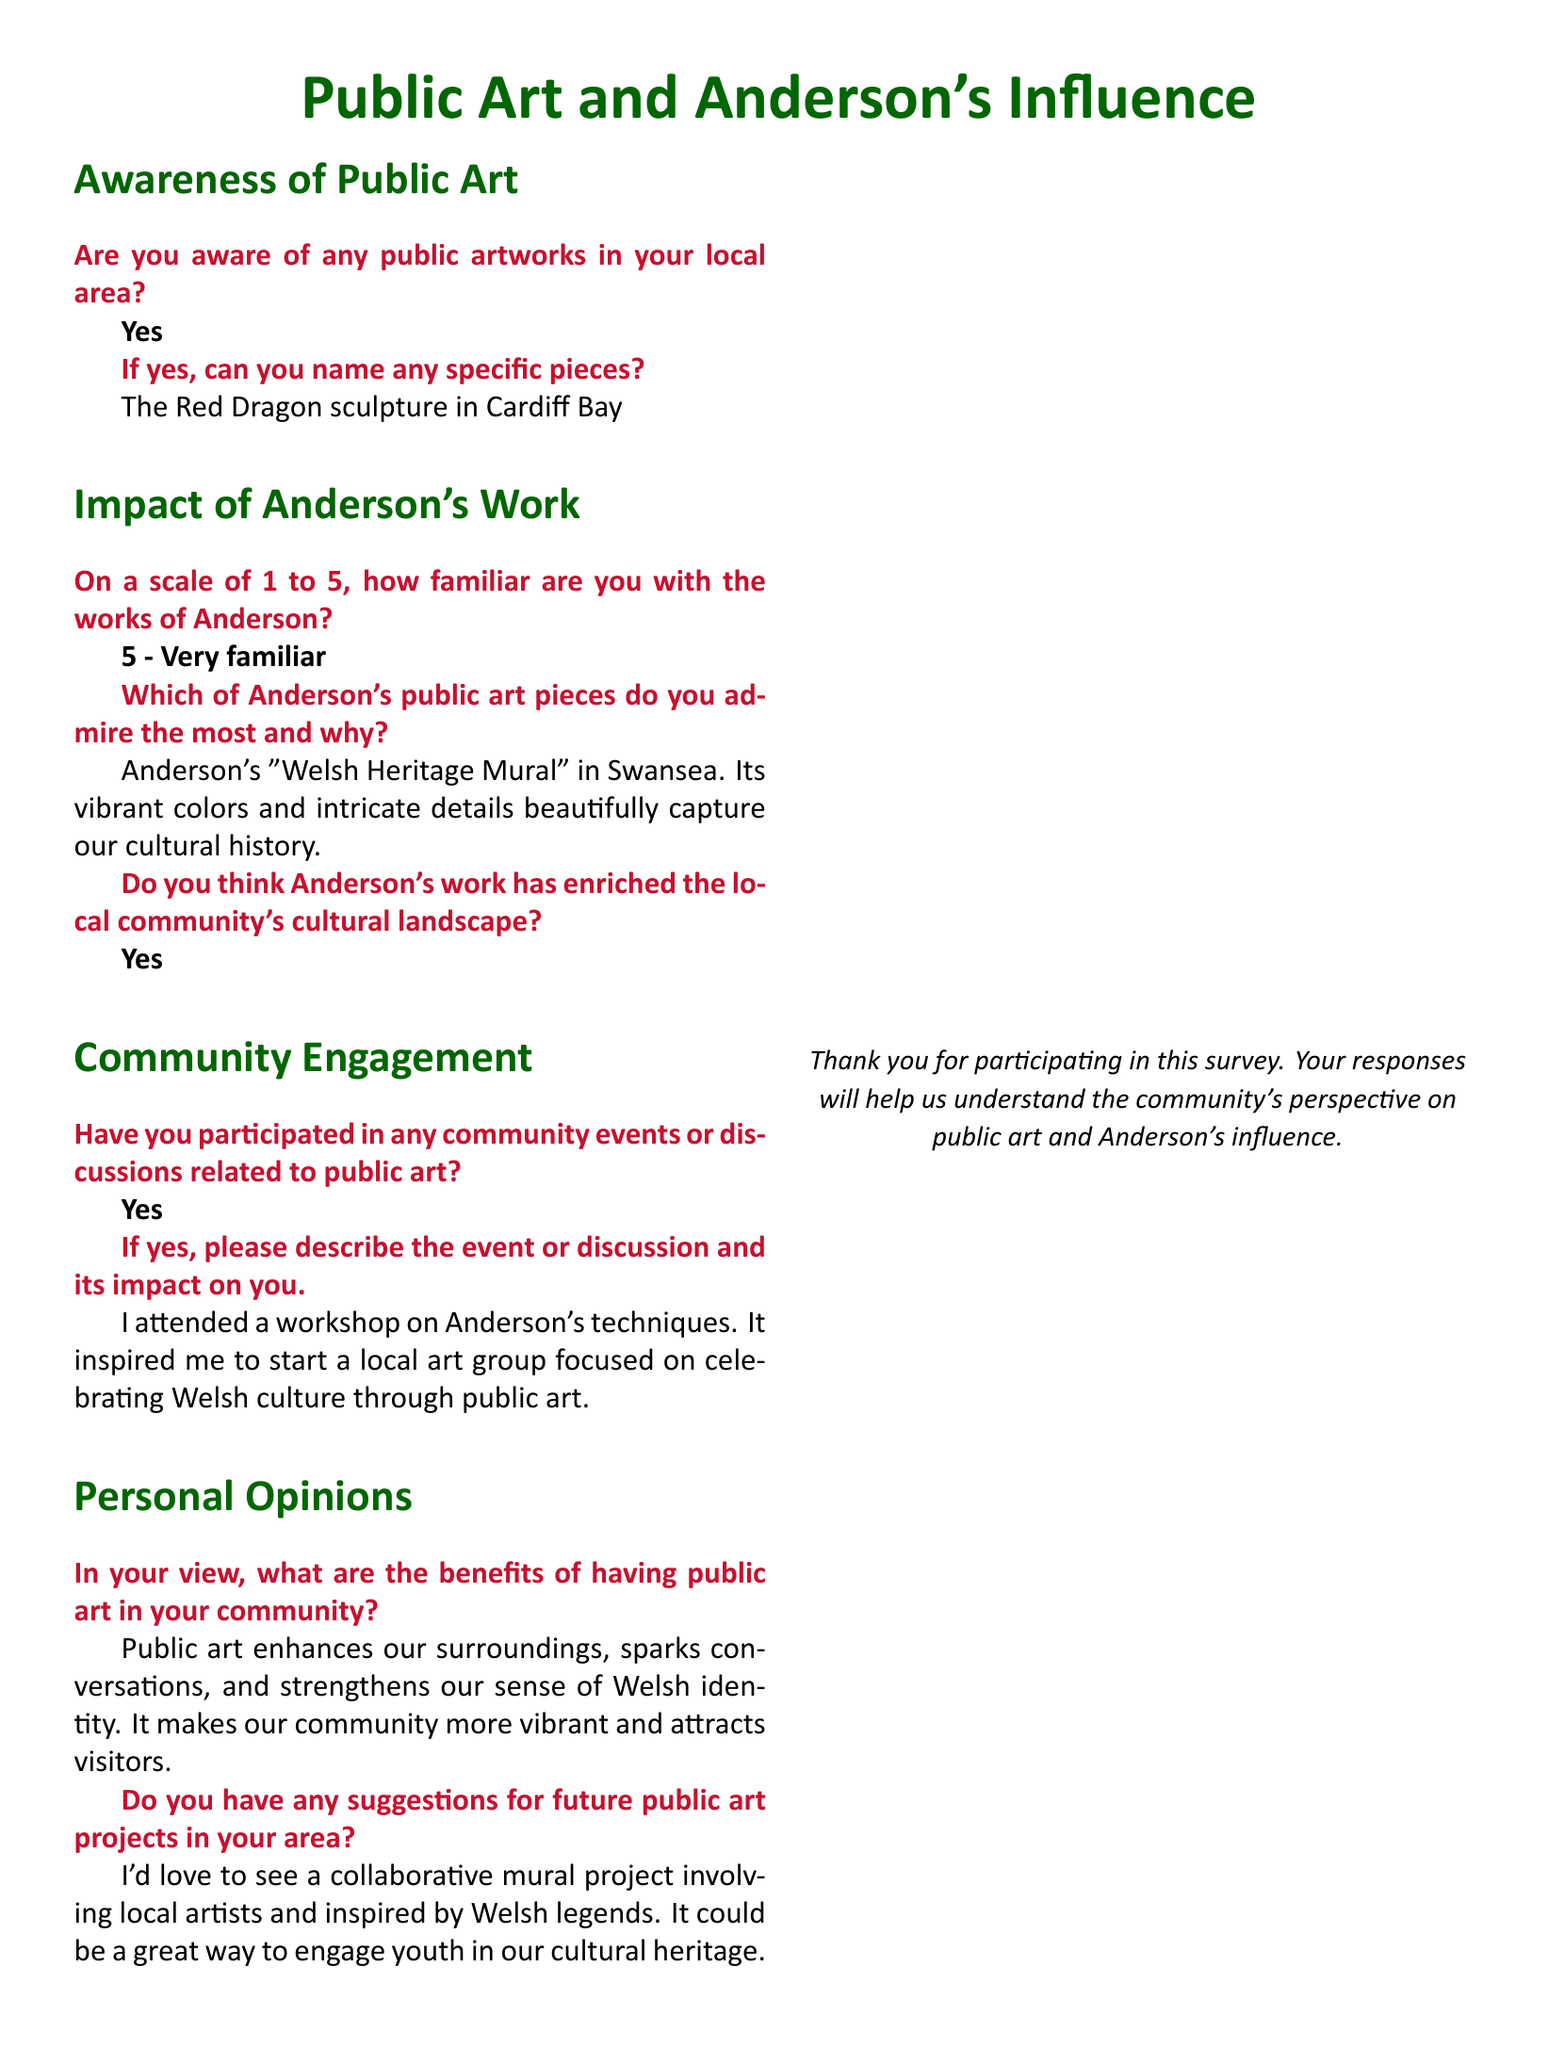what is the name of a public artwork mentioned in the survey? The survey specifically mentions "The Red Dragon sculpture in Cardiff Bay" as a public artwork.
Answer: The Red Dragon sculpture in Cardiff Bay how familiar are respondents with Anderson's works? Respondents indicated their familiarity with Anderson's works on a scale of 1 to 5, with one respondent selecting 5.
Answer: 5 which public art piece of Anderson is most admired according to the survey? The survey identifies Anderson's "Welsh Heritage Mural" in Swansea as the most admired public art piece among respondents.
Answer: Welsh Heritage Mural did participants believe Anderson's work enriched the community's culture? The survey explicitly states that respondents believe Anderson's work has enriched the local community's cultural landscape.
Answer: Yes what impact did a community event have on a respondent? One respondent mentioned attending a workshop on Anderson's techniques, which inspired them to start a local art group.
Answer: Inspired to start a local art group what suggestion is made for future public art projects? A suggestion was made for a collaborative mural project involving local artists inspired by Welsh legends to engage youth.
Answer: Collaborative mural project what are some benefits of public art according to the survey respondent? Respondents noted that public art enhances surroundings, sparks conversations, and strengthens community identity.
Answer: Enhances surroundings, sparks conversations, strengthens identity 